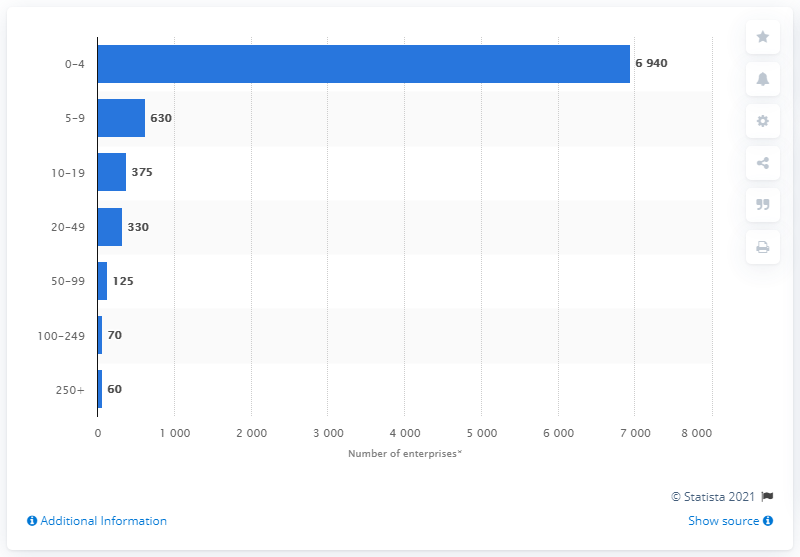Outline some significant characteristics in this image. In 2020, approximately 60 people were employed by the 80 companies in the telecommunications sector in the United Kingdom. 